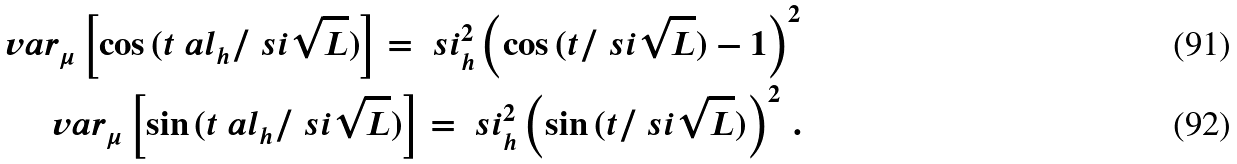Convert formula to latex. <formula><loc_0><loc_0><loc_500><loc_500>\ v a r _ { \mu } \left [ \cos { ( t \ a l _ { h } / { \ s i \sqrt { L } } ) } \right ] = \ s i ^ { 2 } _ { h } \left ( \cos { ( t / { \ s i \sqrt { L } } ) } - 1 \right ) ^ { 2 } \\ \ v a r _ { \mu } \left [ \sin { ( t \ a l _ { h } / { \ s i \sqrt { L } } ) } \right ] = \ s i ^ { 2 } _ { h } \left ( \sin { ( t / { \ s i \sqrt { L } } ) } \right ) ^ { 2 } \, .</formula> 